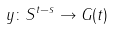Convert formula to latex. <formula><loc_0><loc_0><loc_500><loc_500>y \colon S ^ { t - s } \rightarrow G ( t )</formula> 